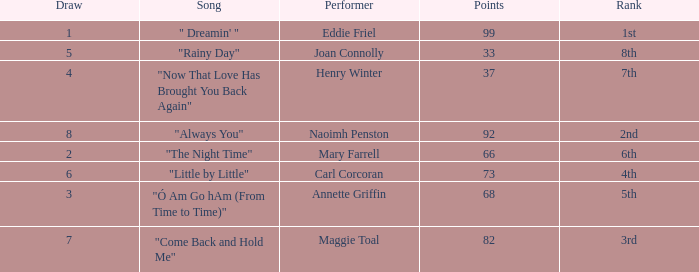What is the lowest points when the ranking is 1st? 99.0. 